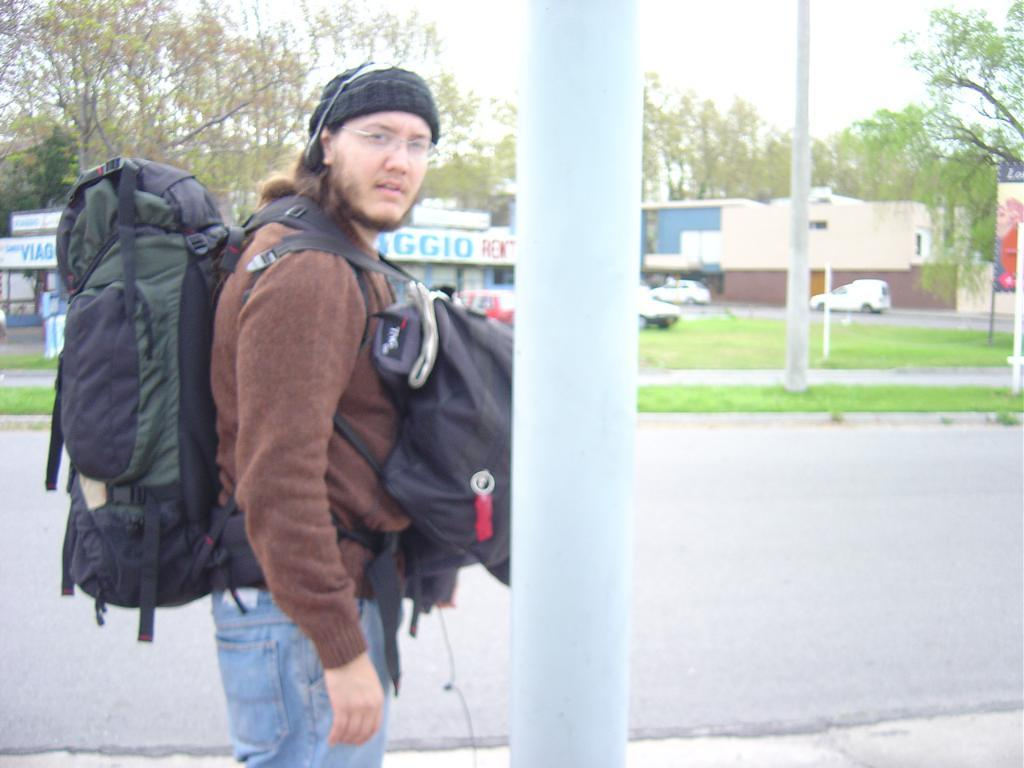What is the main subject of the image? There is a person in the image. What is the person carrying in the image? The person is carrying bags on the front and back. Where is the person standing in the image? The person is standing at a pole. What can be seen in the background of the image? Trees, the sky, a pole, vehicles, a hoarding, and buildings can be seen in the background of the image. What type of hat is the person wearing in the image? There is no hat visible in the image. How is the person dividing their time between work and leisure in the image? The image does not provide information about the person's work or leisure activities, so it cannot be determined how they are dividing their time. 